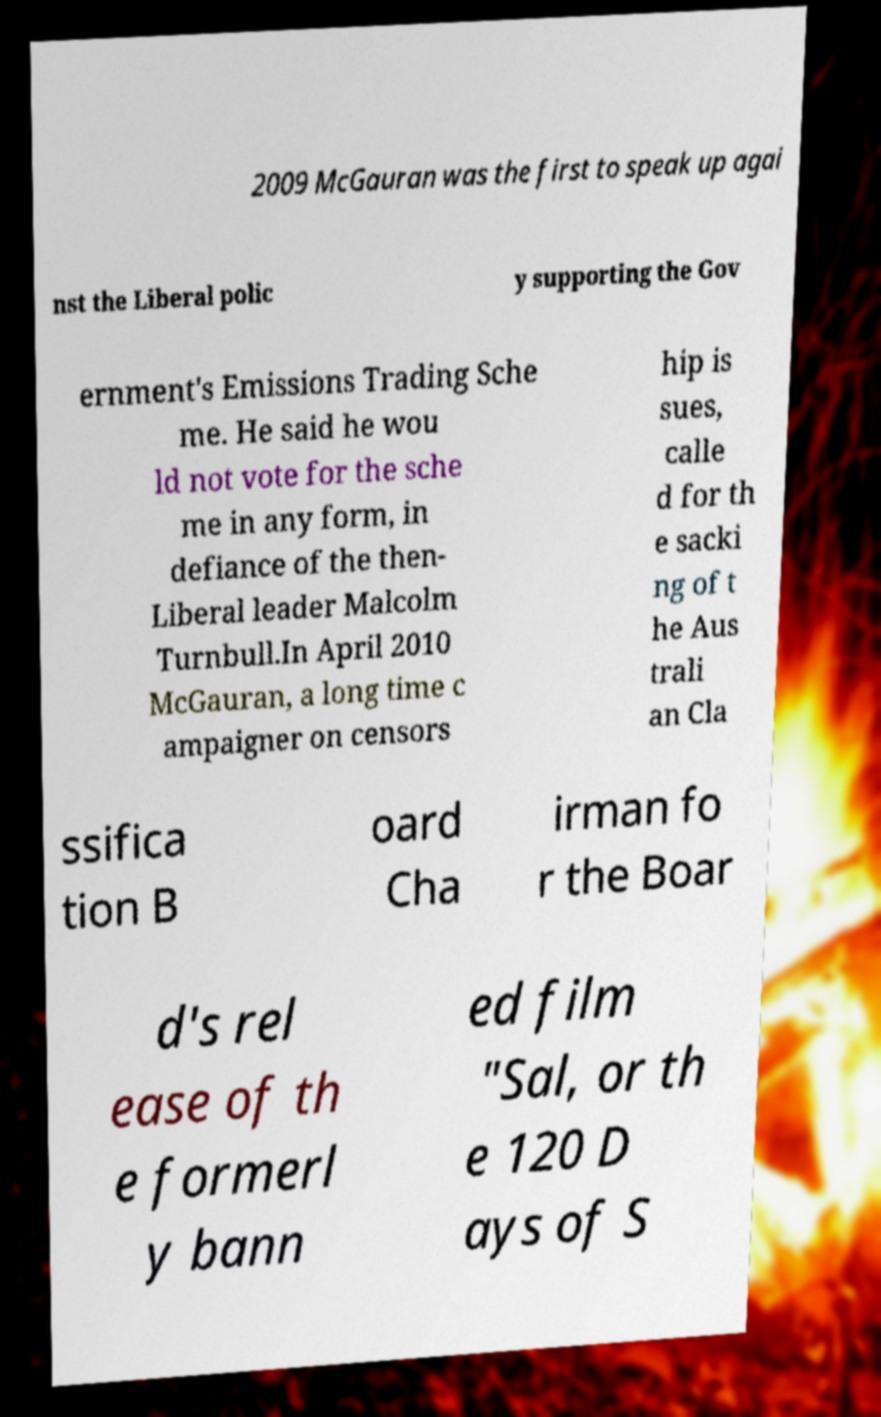I need the written content from this picture converted into text. Can you do that? 2009 McGauran was the first to speak up agai nst the Liberal polic y supporting the Gov ernment's Emissions Trading Sche me. He said he wou ld not vote for the sche me in any form, in defiance of the then- Liberal leader Malcolm Turnbull.In April 2010 McGauran, a long time c ampaigner on censors hip is sues, calle d for th e sacki ng of t he Aus trali an Cla ssifica tion B oard Cha irman fo r the Boar d's rel ease of th e formerl y bann ed film "Sal, or th e 120 D ays of S 